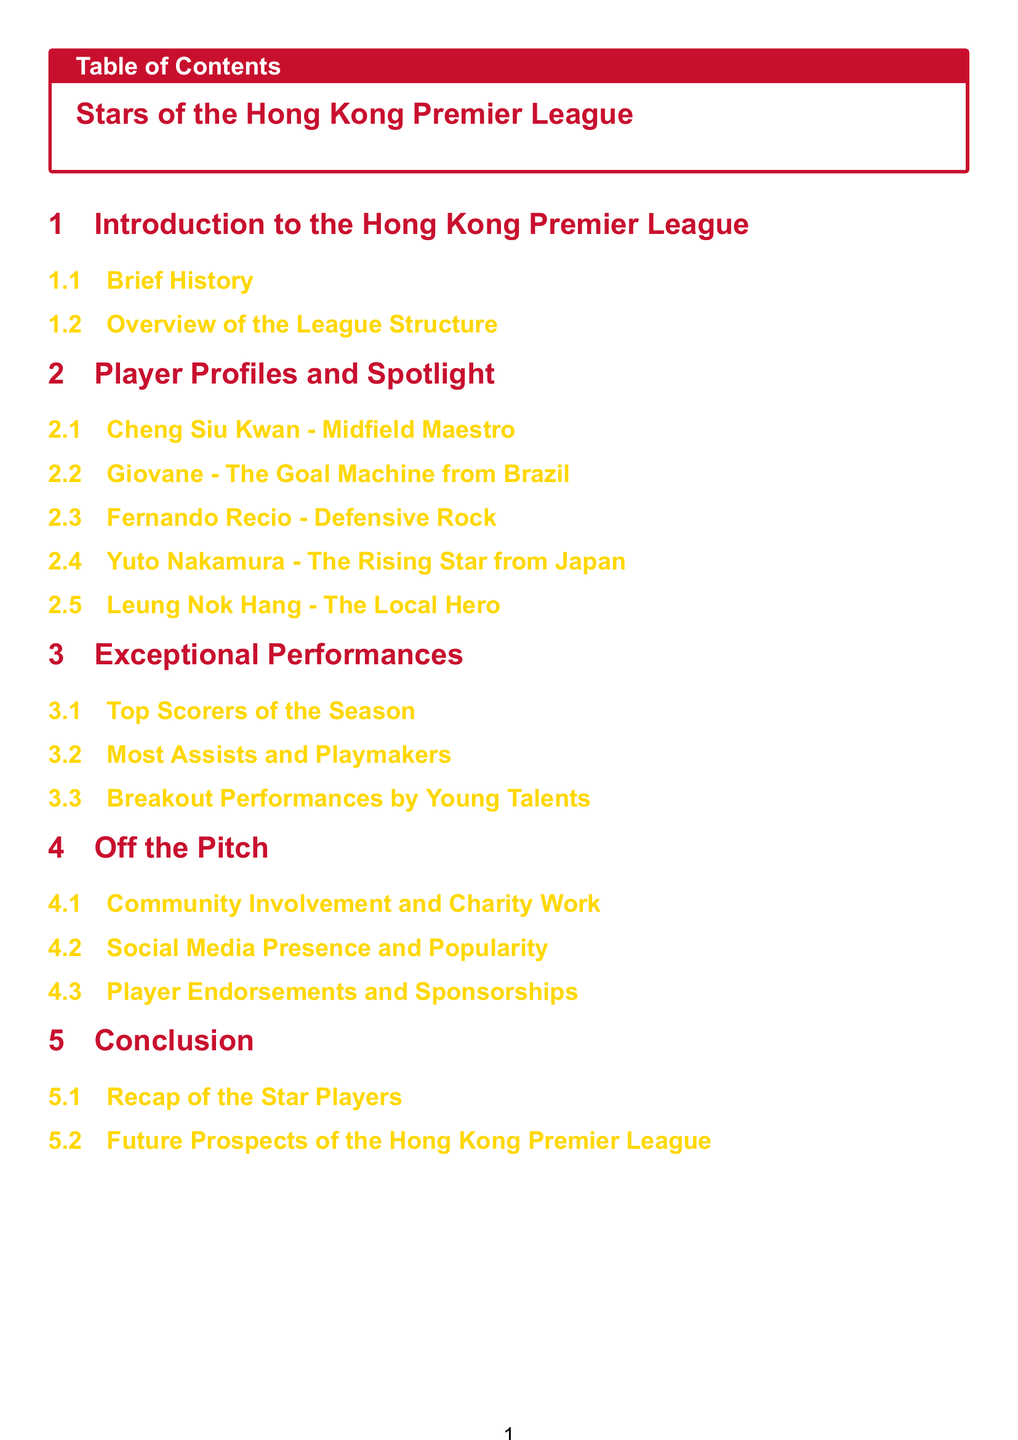What is the title of the section that contains player profiles? The title of the section is explicitly mentioned in the Table of Contents, which is "Player Profiles and Spotlight."
Answer: Player Profiles and Spotlight Who is the midfield maestro featured in the document? The name of the player described as the midfield maestro is provided in the section on player profiles.
Answer: Cheng Siu Kwan Which player is referred to as the local hero? The document lists specific players, one of whom is designated as the local hero in the profiles section.
Answer: Leung Nok Hang How many players are spotlighted in the Player Profiles section? By counting the subsections listed under Player Profiles and Spotlight, we can determine the number of players spotlighted.
Answer: Five What type of performances are highlighted in the Exceptional Performances section? The subheadings of this section provide insights into specific types of player performances, including one category.
Answer: Top Scorers What is the focus of the Off the Pitch section? This section includes various aspects outside of gameplay, as indicated by the listed subsections.
Answer: Community Involvement and Charity Work Which section concludes the document? The last section is explicitly mentioned in the Table of Contents as the conclusion of the document.
Answer: Conclusion Who is the rising star from Japan? The document specifies a player recognized as the rising star from Japan in the Player Profiles section.
Answer: Yuto Nakamura 